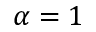<formula> <loc_0><loc_0><loc_500><loc_500>\alpha = 1</formula> 